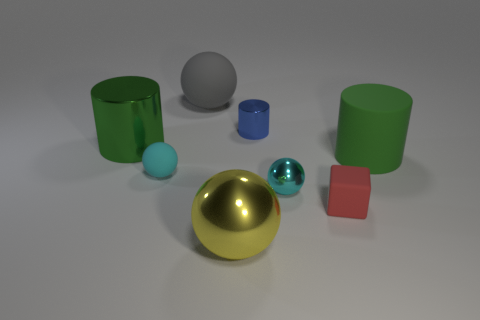There is a small metal thing in front of the small rubber ball; is its color the same as the tiny matte sphere?
Give a very brief answer. Yes. Do the blue object and the tiny red object have the same material?
Your response must be concise. No. Is the large rubber cylinder the same color as the large metal cylinder?
Make the answer very short. Yes. There is a object that is the same color as the large shiny cylinder; what is its size?
Ensure brevity in your answer.  Large. What is the size of the object that is both on the right side of the yellow metallic ball and behind the green metal thing?
Ensure brevity in your answer.  Small. Is there a metallic cylinder of the same color as the matte cylinder?
Make the answer very short. Yes. Is the material of the tiny red thing on the right side of the blue cylinder the same as the large yellow ball?
Provide a succinct answer. No. Are there any other things that are the same color as the matte cylinder?
Provide a short and direct response. Yes. The thing that is right of the small shiny ball and behind the tiny cube has what shape?
Your answer should be very brief. Cylinder. Are there the same number of tiny red objects that are on the right side of the small cube and tiny things that are behind the rubber cylinder?
Your answer should be very brief. No. 